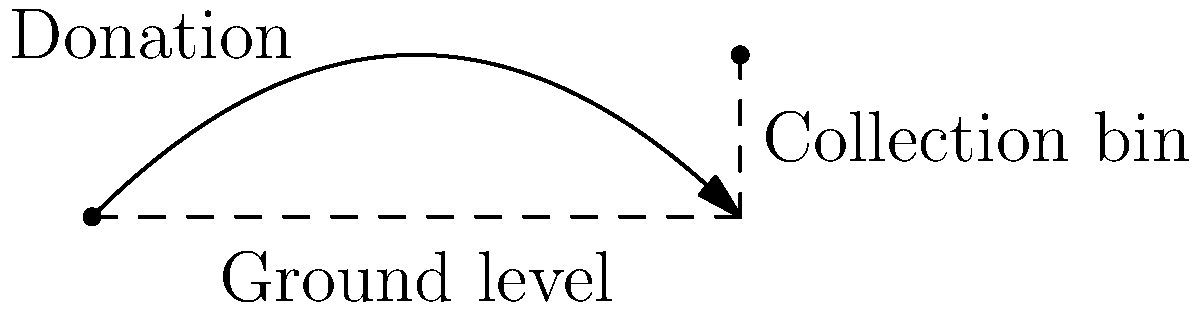As part of a charity event, you're throwing a donation into a collection bin. If you throw the donation with an initial velocity of 10 m/s at a 45° angle from the ground, and the bin is 10 meters away, what is the height of the bin needed to catch the donation? Assume air resistance is negligible. To solve this problem, we'll use the equations of projectile motion:

1. Horizontal distance: $x = v_0 \cos(\theta) t$
2. Vertical distance: $y = v_0 \sin(\theta) t - \frac{1}{2}gt^2$

Where:
$v_0 = 10$ m/s (initial velocity)
$\theta = 45°$ (angle)
$g = 9.8$ m/s² (acceleration due to gravity)
$x = 10$ m (horizontal distance to the bin)

Step 1: Find the time it takes for the donation to reach the bin horizontally.
$10 = 10 \cos(45°) t$
$t = \frac{10}{10 \cos(45°)} = \frac{10}{10 \cdot \frac{\sqrt{2}}{2}} = \sqrt{2}$ seconds

Step 2: Use this time to calculate the height of the donation when it reaches the bin.
$y = 10 \sin(45°) \sqrt{2} - \frac{1}{2} \cdot 9.8 \cdot (\sqrt{2})^2$
$y = 10 \cdot \frac{\sqrt{2}}{2} \cdot \sqrt{2} - \frac{1}{2} \cdot 9.8 \cdot 2$
$y = 10 - 9.8 = 0.2$ meters

Therefore, the bin needs to be 0.2 meters (20 cm) high to catch the donation.
Answer: 0.2 meters 